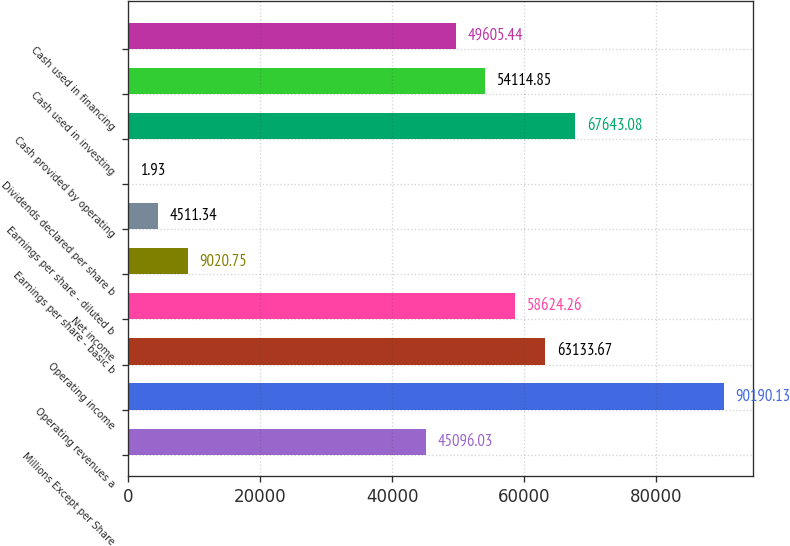<chart> <loc_0><loc_0><loc_500><loc_500><bar_chart><fcel>Millions Except per Share<fcel>Operating revenues a<fcel>Operating income<fcel>Net income<fcel>Earnings per share - basic b<fcel>Earnings per share - diluted b<fcel>Dividends declared per share b<fcel>Cash provided by operating<fcel>Cash used in investing<fcel>Cash used in financing<nl><fcel>45096<fcel>90190.1<fcel>63133.7<fcel>58624.3<fcel>9020.75<fcel>4511.34<fcel>1.93<fcel>67643.1<fcel>54114.8<fcel>49605.4<nl></chart> 